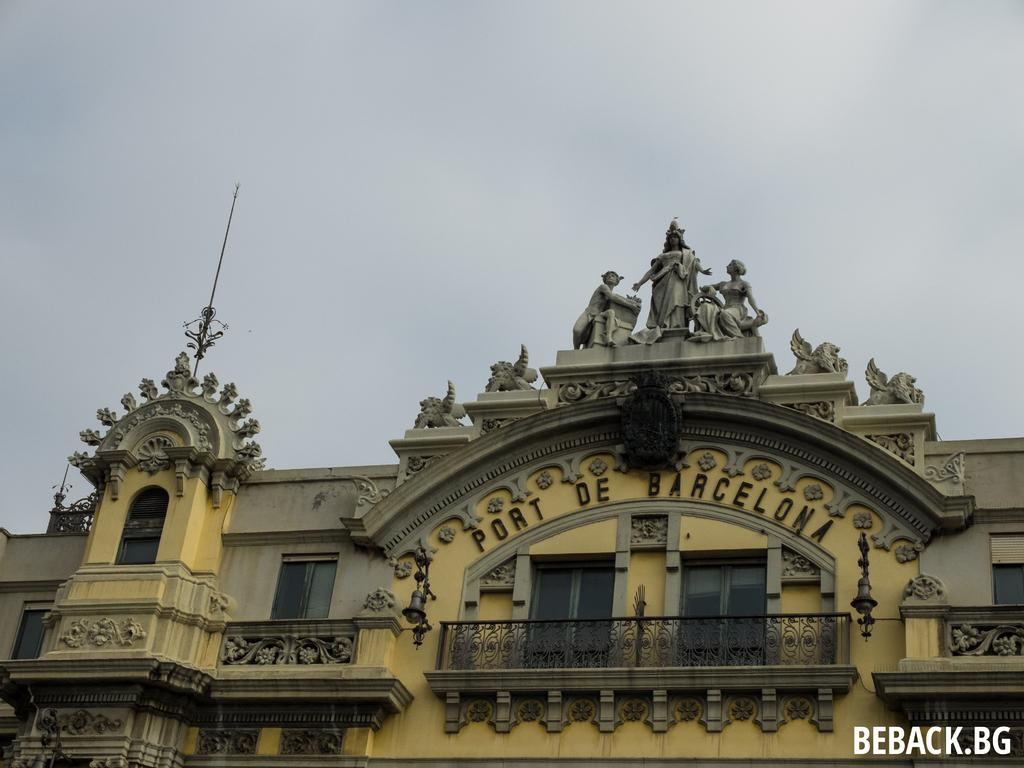<image>
Share a concise interpretation of the image provided. A building with Port De Barcelona written on the top of it. 